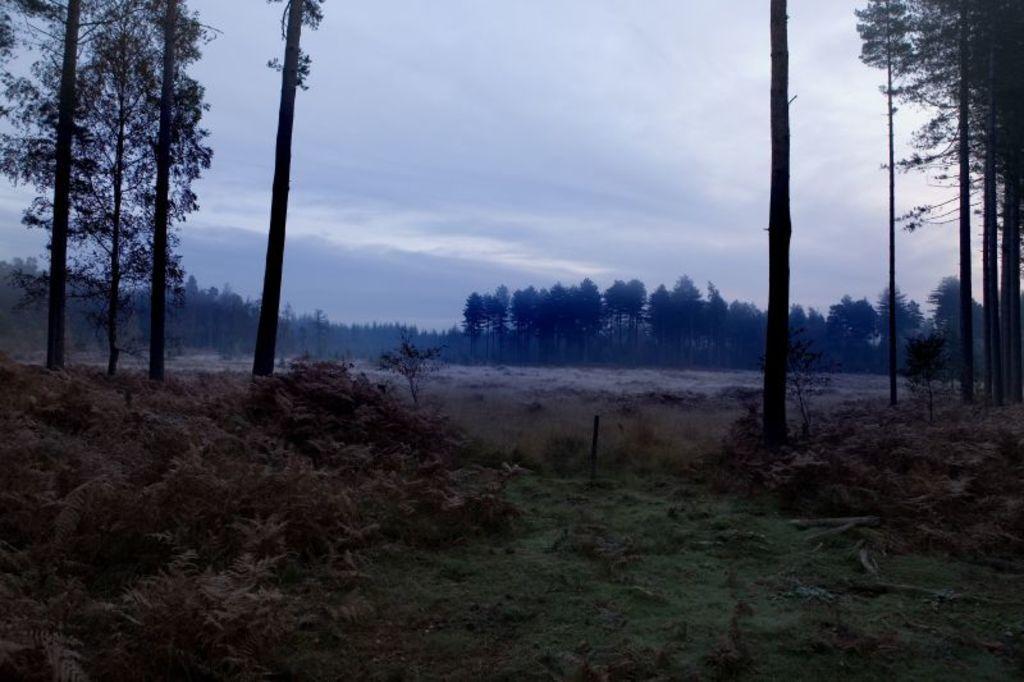Could you give a brief overview of what you see in this image? In this image we can see a river, there are some trees, plants and bushes, and also we can see the sky. 